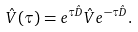<formula> <loc_0><loc_0><loc_500><loc_500>\hat { V } ( \tau ) = e ^ { \tau \hat { D } } \hat { V } e ^ { - \tau \hat { D } } .</formula> 